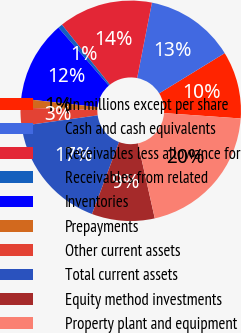Convert chart. <chart><loc_0><loc_0><loc_500><loc_500><pie_chart><fcel>(In millions except per share<fcel>Cash and cash equivalents<fcel>Receivables less allowance for<fcel>Receivables from related<fcel>Inventories<fcel>Prepayments<fcel>Other current assets<fcel>Total current assets<fcel>Equity method investments<fcel>Property plant and equipment<nl><fcel>9.87%<fcel>13.16%<fcel>13.81%<fcel>0.66%<fcel>11.84%<fcel>1.32%<fcel>2.64%<fcel>17.1%<fcel>9.21%<fcel>20.39%<nl></chart> 